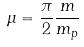<formula> <loc_0><loc_0><loc_500><loc_500>\mu = \frac { \pi } { 2 } \frac { m } { m _ { p } }</formula> 